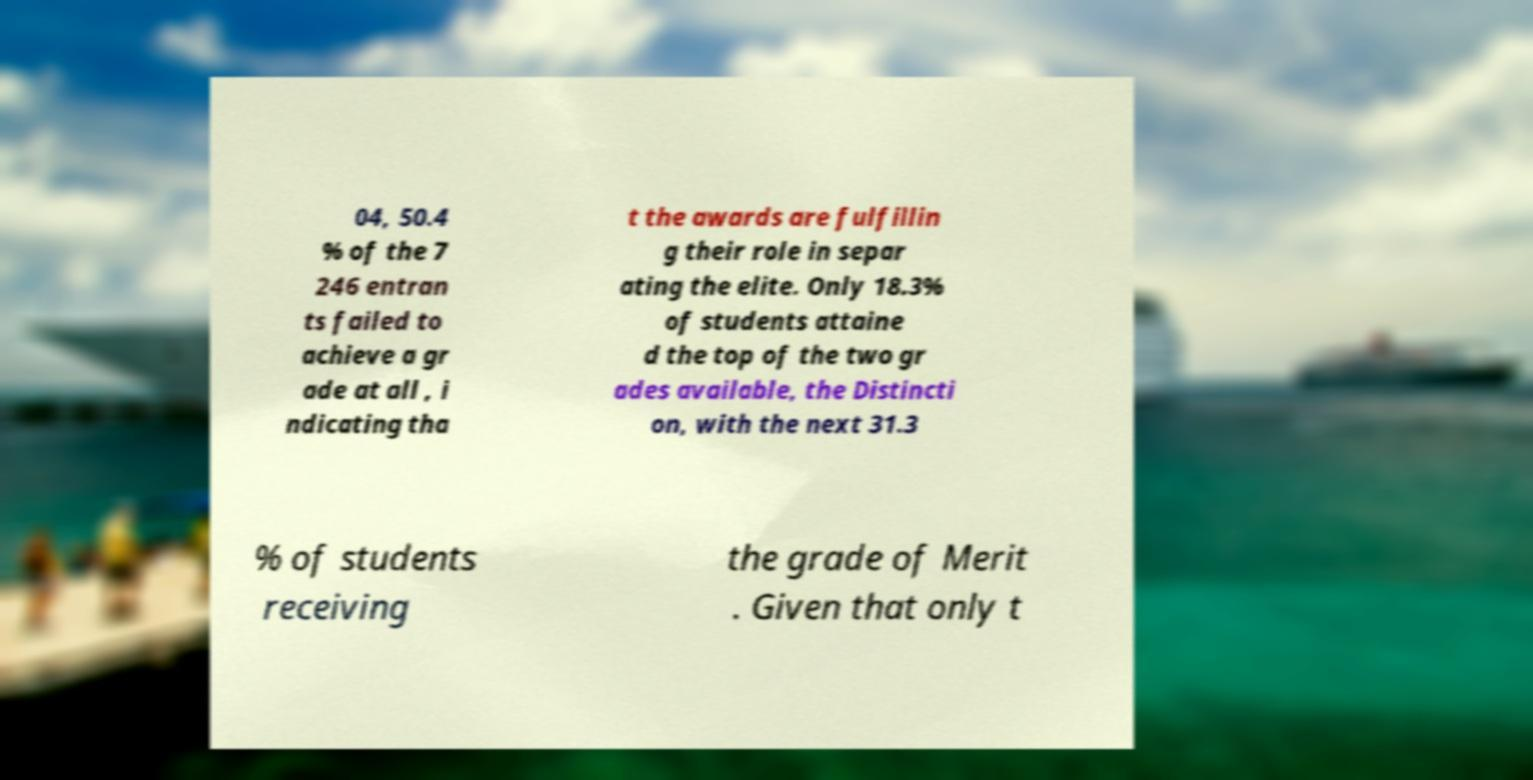I need the written content from this picture converted into text. Can you do that? 04, 50.4 % of the 7 246 entran ts failed to achieve a gr ade at all , i ndicating tha t the awards are fulfillin g their role in separ ating the elite. Only 18.3% of students attaine d the top of the two gr ades available, the Distincti on, with the next 31.3 % of students receiving the grade of Merit . Given that only t 